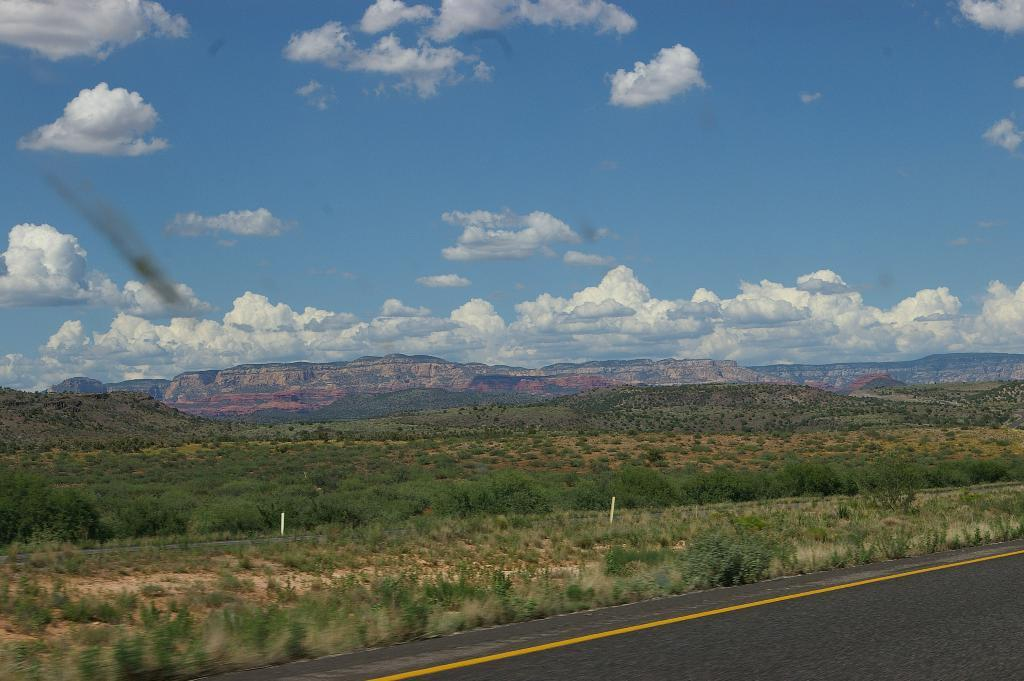Where was the image taken? The image is clicked outside. What can be seen in the middle of the image? There are hills, bushes, and trees in the middle of the image. What is visible at the top of the image? There is sky visible at the top of the image. What type of pencil is being used to draw the trees in the image? There is no pencil or drawing activity present in the image; it is a photograph of real trees and hills. 